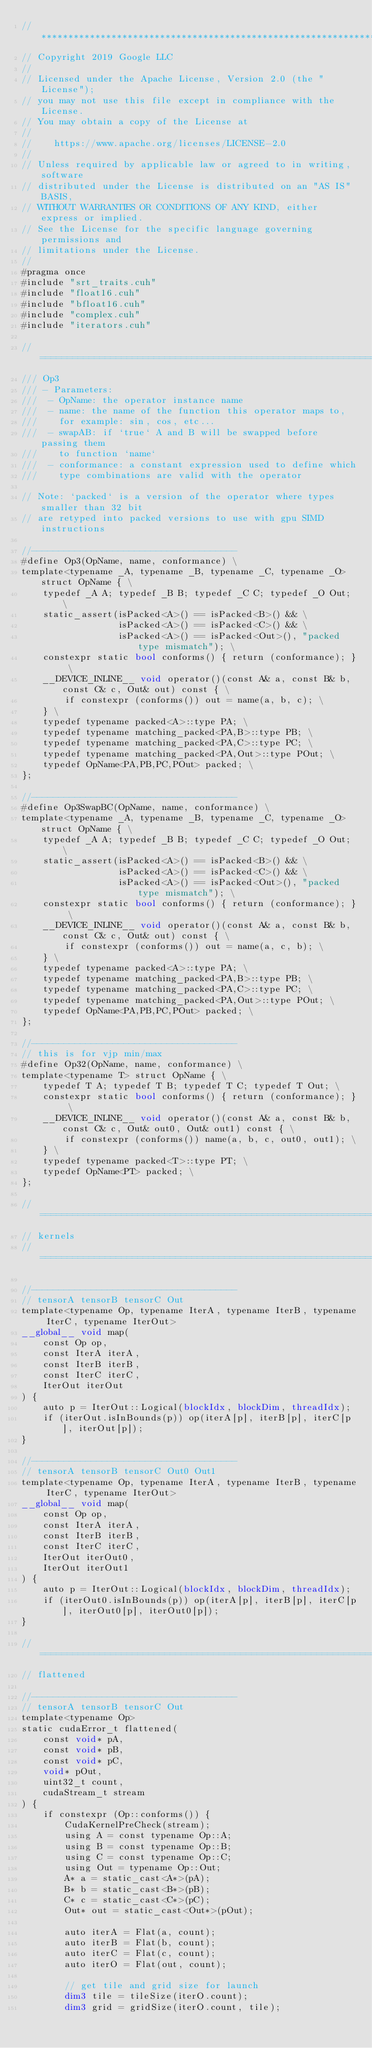<code> <loc_0><loc_0><loc_500><loc_500><_Cuda_>//******************************************************************************
// Copyright 2019 Google LLC
//
// Licensed under the Apache License, Version 2.0 (the "License");
// you may not use this file except in compliance with the License.
// You may obtain a copy of the License at
//
//    https://www.apache.org/licenses/LICENSE-2.0
//
// Unless required by applicable law or agreed to in writing, software
// distributed under the License is distributed on an "AS IS" BASIS,
// WITHOUT WARRANTIES OR CONDITIONS OF ANY KIND, either express or implied.
// See the License for the specific language governing permissions and
// limitations under the License.
//
#pragma once
#include "srt_traits.cuh"
#include "float16.cuh"
#include "bfloat16.cuh"
#include "complex.cuh"
#include "iterators.cuh"

//==============================================================================
/// Op3
/// - Parameters:
///  - OpName: the operator instance name
///  - name: the name of the function this operator maps to,
///    for example: sin, cos, etc...
///  - swapAB: if `true` A and B will be swapped before passing them
///    to function `name`
///  - conformance: a constant expression used to define which
///    type combinations are valid with the operator

// Note: `packed` is a version of the operator where types smaller than 32 bit
// are retyped into packed versions to use with gpu SIMD instructions

//--------------------------------------
#define Op3(OpName, name, conformance) \
template<typename _A, typename _B, typename _C, typename _O> struct OpName { \
    typedef _A A; typedef _B B; typedef _C C; typedef _O Out; \
    static_assert(isPacked<A>() == isPacked<B>() && \
                  isPacked<A>() == isPacked<C>() && \
                  isPacked<A>() == isPacked<Out>(), "packed type mismatch"); \
    constexpr static bool conforms() { return (conformance); } \
    __DEVICE_INLINE__ void operator()(const A& a, const B& b, const C& c, Out& out) const { \
        if constexpr (conforms()) out = name(a, b, c); \
    } \
    typedef typename packed<A>::type PA; \
    typedef typename matching_packed<PA,B>::type PB; \
    typedef typename matching_packed<PA,C>::type PC; \
    typedef typename matching_packed<PA,Out>::type POut; \
    typedef OpName<PA,PB,PC,POut> packed; \
};

//--------------------------------------
#define Op3SwapBC(OpName, name, conformance) \
template<typename _A, typename _B, typename _C, typename _O> struct OpName { \
    typedef _A A; typedef _B B; typedef _C C; typedef _O Out; \
    static_assert(isPacked<A>() == isPacked<B>() && \
                  isPacked<A>() == isPacked<C>() && \
                  isPacked<A>() == isPacked<Out>(), "packed type mismatch"); \
    constexpr static bool conforms() { return (conformance); } \
    __DEVICE_INLINE__ void operator()(const A& a, const B& b, const C& c, Out& out) const { \
        if constexpr (conforms()) out = name(a, c, b); \
    } \
    typedef typename packed<A>::type PA; \
    typedef typename matching_packed<PA,B>::type PB; \
    typedef typename matching_packed<PA,C>::type PC; \
    typedef typename matching_packed<PA,Out>::type POut; \
    typedef OpName<PA,PB,PC,POut> packed; \
};

//--------------------------------------
// this is for vjp min/max
#define Op32(OpName, name, conformance) \
template<typename T> struct OpName { \
    typedef T A; typedef T B; typedef T C; typedef T Out; \
    constexpr static bool conforms() { return (conformance); } \
    __DEVICE_INLINE__ void operator()(const A& a, const B& b, const C& c, Out& out0, Out& out1) const { \
        if constexpr (conforms()) name(a, b, c, out0, out1); \
    } \
    typedef typename packed<T>::type PT; \
    typedef OpName<PT> packed; \
};

//==============================================================================
// kernels
//==============================================================================

//--------------------------------------
// tensorA tensorB tensorC Out
template<typename Op, typename IterA, typename IterB, typename IterC, typename IterOut>
__global__ void map(
    const Op op,
    const IterA iterA,
    const IterB iterB,
    const IterC iterC,
    IterOut iterOut
) {
    auto p = IterOut::Logical(blockIdx, blockDim, threadIdx);
    if (iterOut.isInBounds(p)) op(iterA[p], iterB[p], iterC[p], iterOut[p]);
}

//--------------------------------------
// tensorA tensorB tensorC Out0 Out1
template<typename Op, typename IterA, typename IterB, typename IterC, typename IterOut>
__global__ void map(
    const Op op,
    const IterA iterA,
    const IterB iterB,
    const IterC iterC,
    IterOut iterOut0,
    IterOut iterOut1
) {
    auto p = IterOut::Logical(blockIdx, blockDim, threadIdx);
    if (iterOut0.isInBounds(p)) op(iterA[p], iterB[p], iterC[p], iterOut0[p], iterOut0[p]);
}

//==============================================================================
// flattened

//--------------------------------------
// tensorA tensorB tensorC Out
template<typename Op>
static cudaError_t flattened(
    const void* pA,
    const void* pB,
    const void* pC,
    void* pOut,
    uint32_t count,
    cudaStream_t stream
) {
    if constexpr (Op::conforms()) {
        CudaKernelPreCheck(stream);
        using A = const typename Op::A;
        using B = const typename Op::B;
        using C = const typename Op::C;
        using Out = typename Op::Out;
        A* a = static_cast<A*>(pA);
        B* b = static_cast<B*>(pB);
        C* c = static_cast<C*>(pC);
        Out* out = static_cast<Out*>(pOut);

        auto iterA = Flat(a, count);
        auto iterB = Flat(b, count);
        auto iterC = Flat(c, count);
        auto iterO = Flat(out, count);

        // get tile and grid size for launch
        dim3 tile = tileSize(iterO.count);
        dim3 grid = gridSize(iterO.count, tile);
</code> 